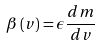<formula> <loc_0><loc_0><loc_500><loc_500>\beta \left ( v \right ) = \epsilon \frac { d m } { d v }</formula> 